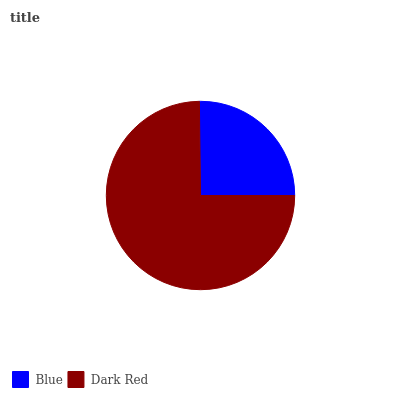Is Blue the minimum?
Answer yes or no. Yes. Is Dark Red the maximum?
Answer yes or no. Yes. Is Dark Red the minimum?
Answer yes or no. No. Is Dark Red greater than Blue?
Answer yes or no. Yes. Is Blue less than Dark Red?
Answer yes or no. Yes. Is Blue greater than Dark Red?
Answer yes or no. No. Is Dark Red less than Blue?
Answer yes or no. No. Is Dark Red the high median?
Answer yes or no. Yes. Is Blue the low median?
Answer yes or no. Yes. Is Blue the high median?
Answer yes or no. No. Is Dark Red the low median?
Answer yes or no. No. 